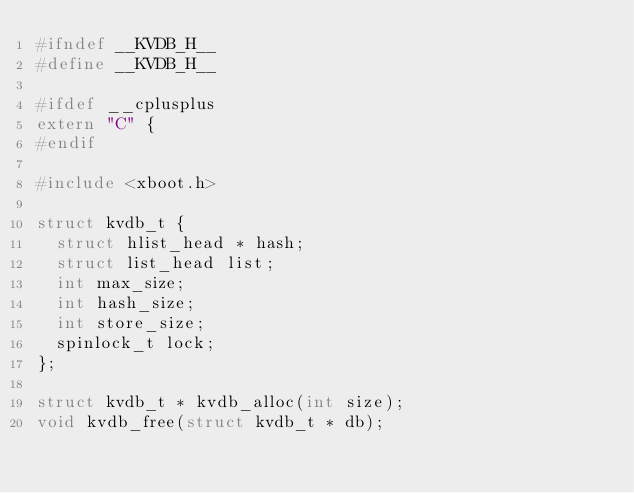Convert code to text. <code><loc_0><loc_0><loc_500><loc_500><_C_>#ifndef __KVDB_H__
#define __KVDB_H__

#ifdef __cplusplus
extern "C" {
#endif

#include <xboot.h>

struct kvdb_t {
	struct hlist_head * hash;
	struct list_head list;
	int max_size;
	int hash_size;
	int store_size;
	spinlock_t lock;
};

struct kvdb_t * kvdb_alloc(int size);
void kvdb_free(struct kvdb_t * db);</code> 